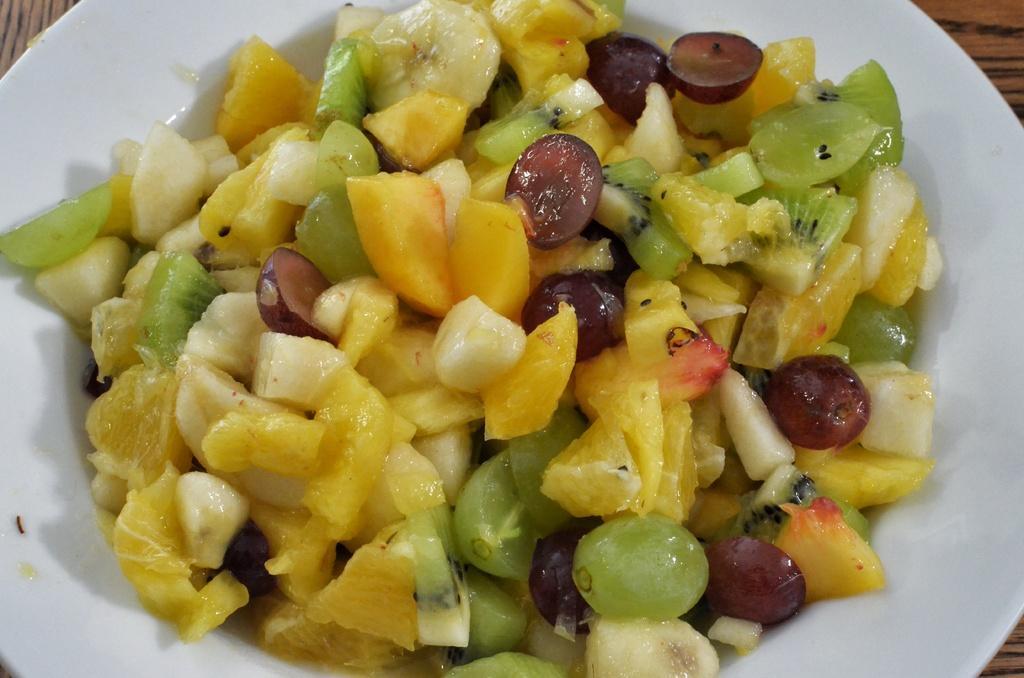Could you give a brief overview of what you see in this image? In this image there is a fruit salad in the bowl kept on a table. 